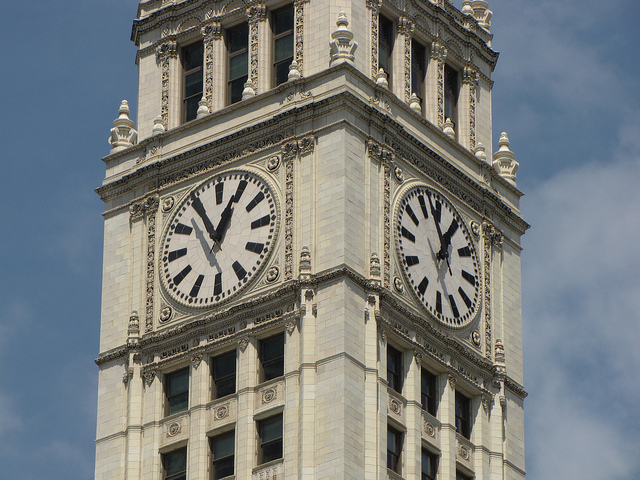<image>Who works in this building? It is unknown who works in this building. It could be anyone from bankers, to office workers, to government officials. Who works in this building? I don't know who works in this building. It can be bankers, clockmaker, parliament, business, men and women, people, office worker, government, or clocksmith. 